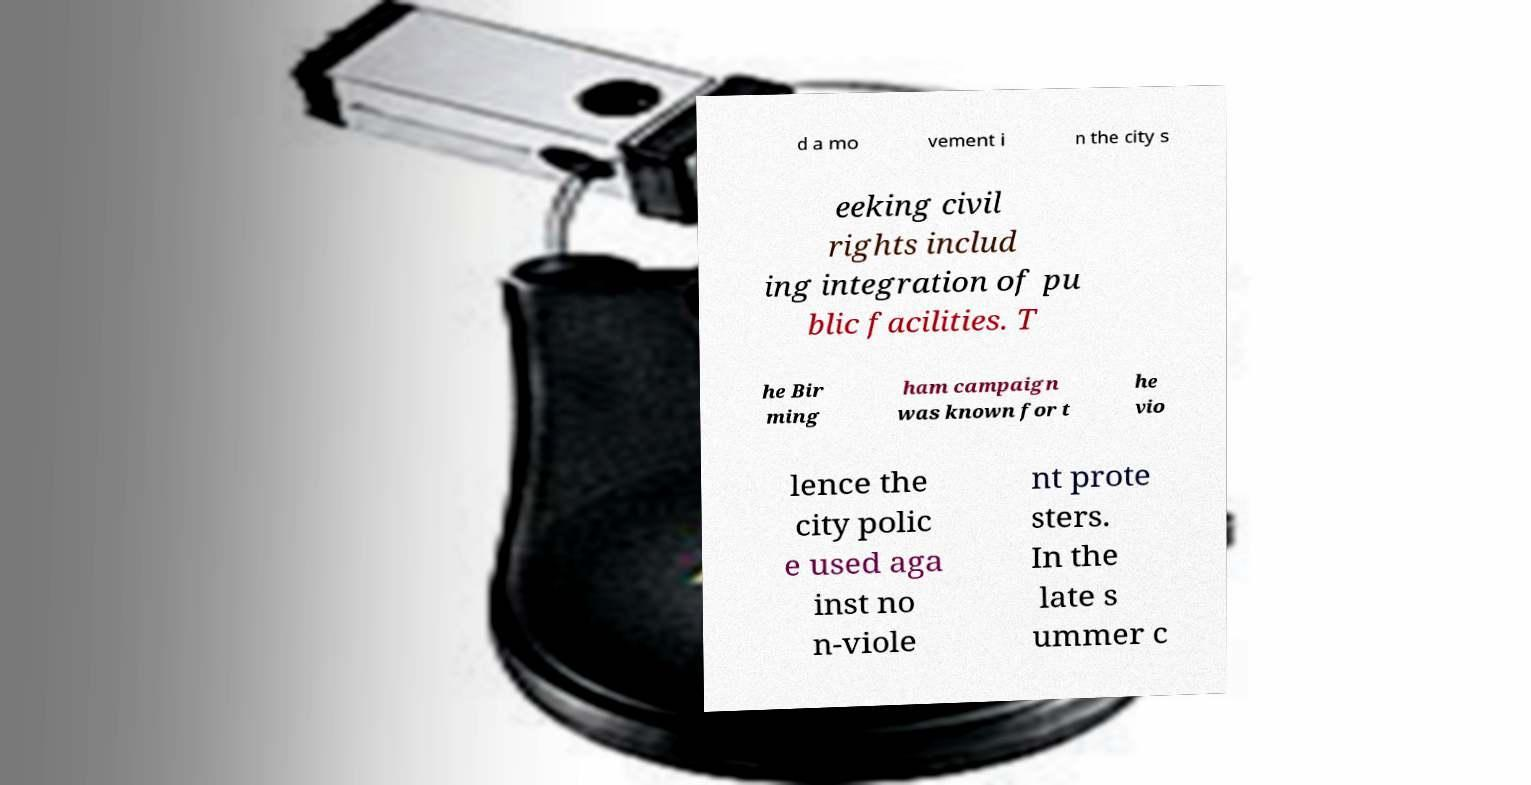There's text embedded in this image that I need extracted. Can you transcribe it verbatim? d a mo vement i n the city s eeking civil rights includ ing integration of pu blic facilities. T he Bir ming ham campaign was known for t he vio lence the city polic e used aga inst no n-viole nt prote sters. In the late s ummer c 